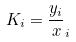Convert formula to latex. <formula><loc_0><loc_0><loc_500><loc_500>K _ { i } = \frac { y _ { i } } { x } _ { i }</formula> 